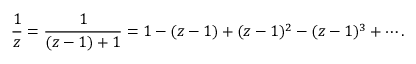Convert formula to latex. <formula><loc_0><loc_0><loc_500><loc_500>{ \frac { 1 } { z } } = { \frac { 1 } { ( z - 1 ) + 1 } } = 1 - ( z - 1 ) + ( z - 1 ) ^ { 2 } - ( z - 1 ) ^ { 3 } + \cdots .</formula> 